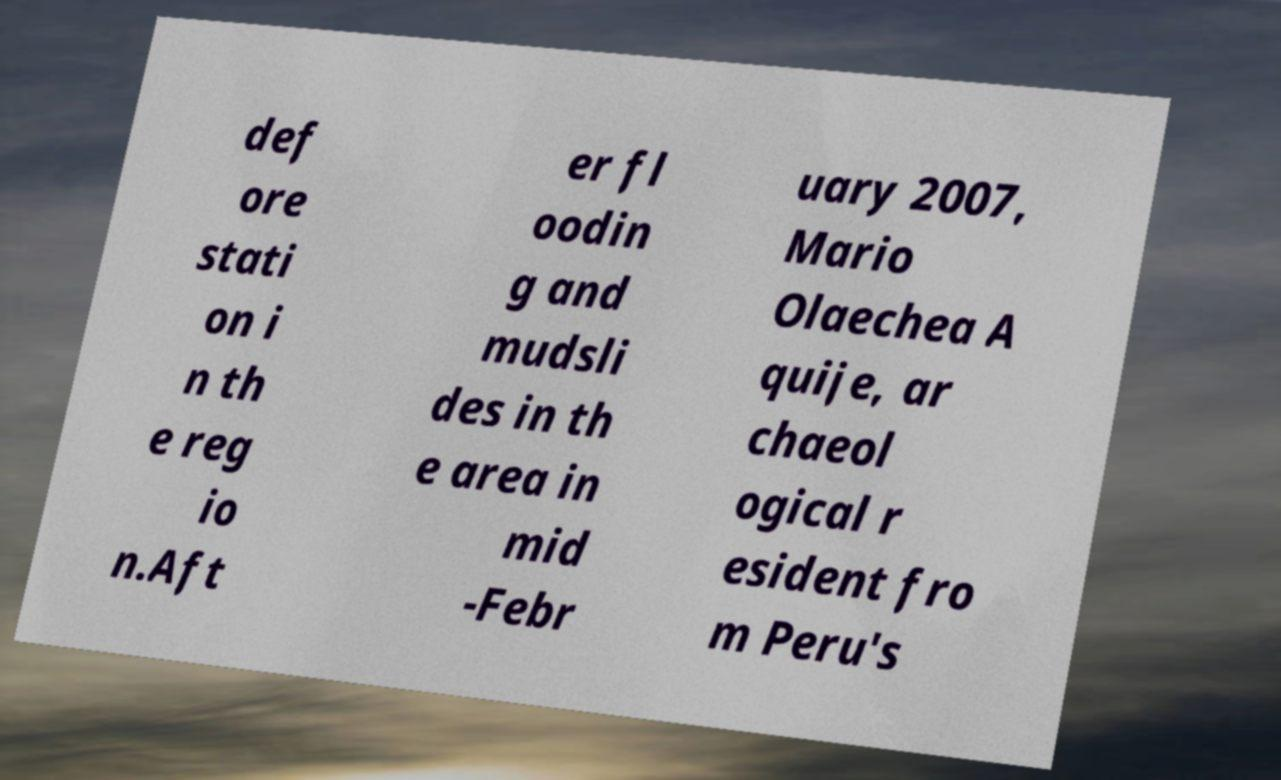Can you accurately transcribe the text from the provided image for me? def ore stati on i n th e reg io n.Aft er fl oodin g and mudsli des in th e area in mid -Febr uary 2007, Mario Olaechea A quije, ar chaeol ogical r esident fro m Peru's 